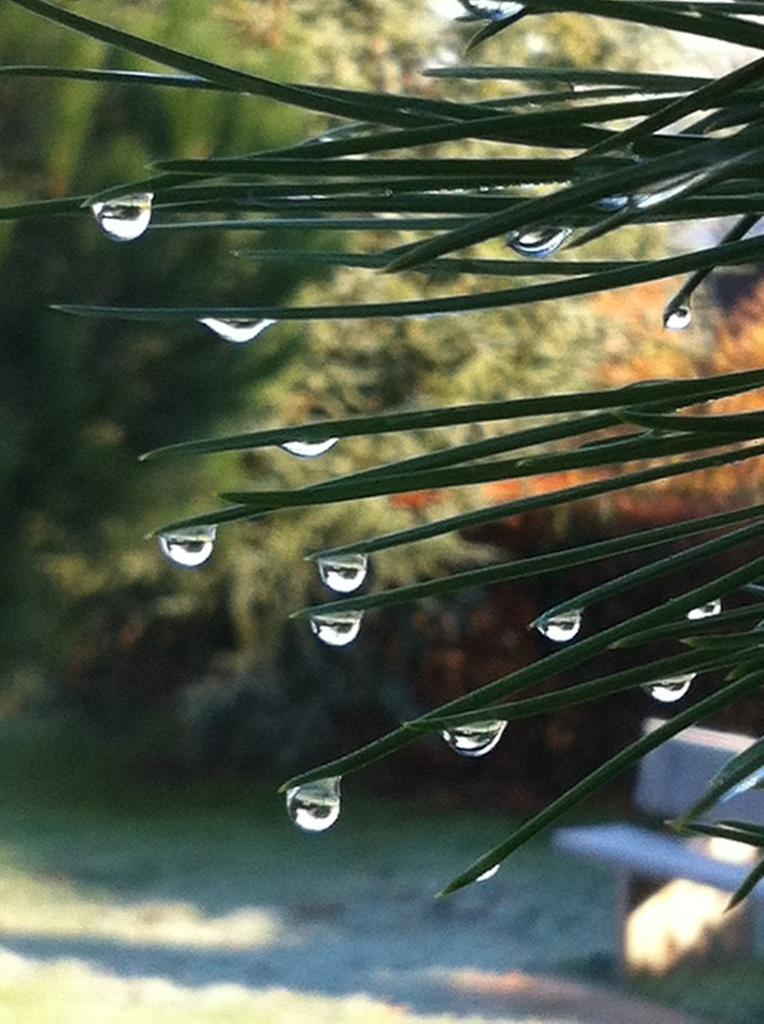What is present on the leaves in the image? There are water drops on the tip of the leaves. What type of vegetation can be seen in the image? There is grass visible in the image. What type of seating is present in the image? There is a bench in the image. What other type of plant is present in the image besides grass? There are trees in the image. How many tickets are visible on the bench in the image? There are no tickets present in the image; it features water drops on leaves, grass, a bench, and trees. Can you hear the trees crying in the image? Trees do not have the ability to cry, and there is no indication of any sound in the image. 